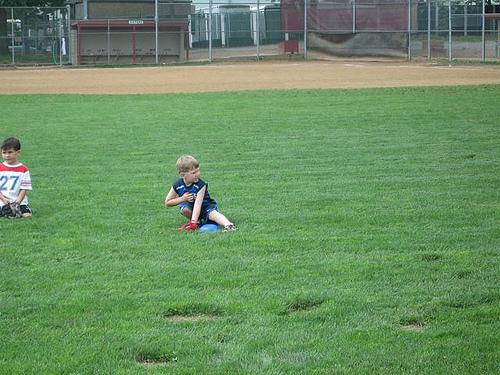What is the red object in the middle of the lawn?
Answer briefly. Glove. What is the next number after the number on the little boy's shirt?
Concise answer only. 28. What type of field is this?
Quick response, please. Baseball. What color is the injured player's uniform?
Quick response, please. Blue. What color is the blonde boy wearing?
Answer briefly. Blue. 